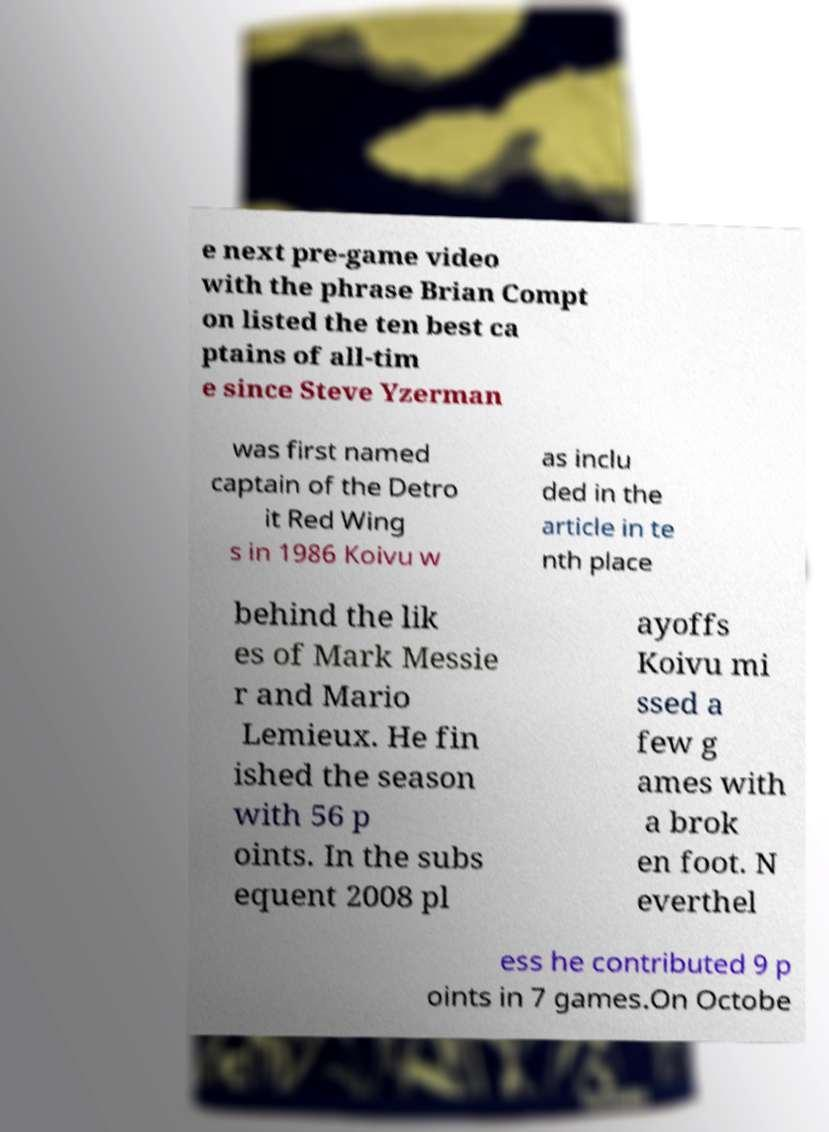Could you extract and type out the text from this image? e next pre-game video with the phrase Brian Compt on listed the ten best ca ptains of all-tim e since Steve Yzerman was first named captain of the Detro it Red Wing s in 1986 Koivu w as inclu ded in the article in te nth place behind the lik es of Mark Messie r and Mario Lemieux. He fin ished the season with 56 p oints. In the subs equent 2008 pl ayoffs Koivu mi ssed a few g ames with a brok en foot. N everthel ess he contributed 9 p oints in 7 games.On Octobe 